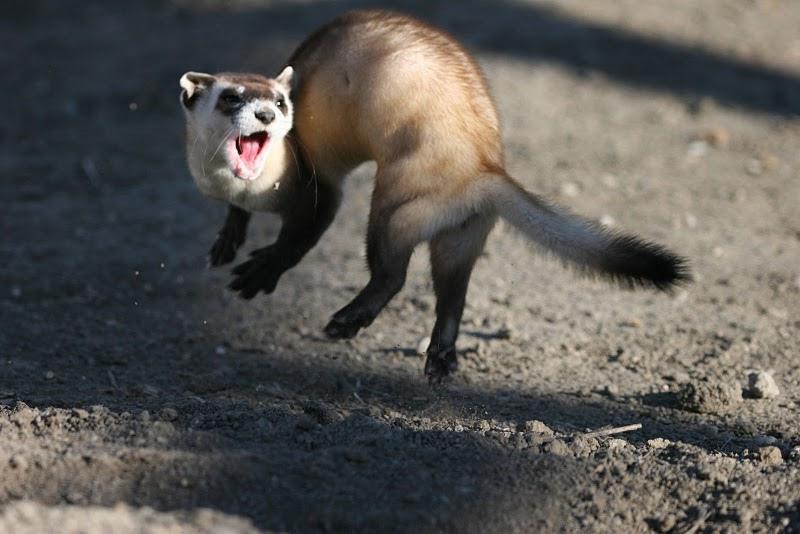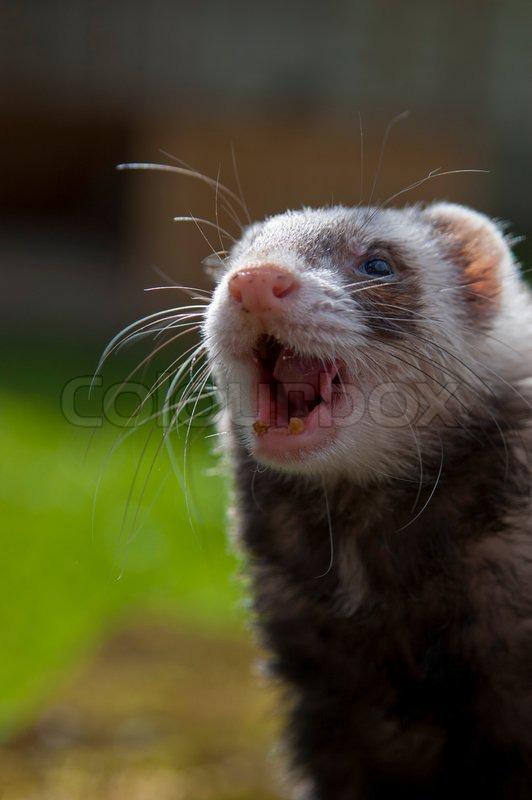The first image is the image on the left, the second image is the image on the right. Considering the images on both sides, is "Two ferrets have their mouths open." valid? Answer yes or no. Yes. 